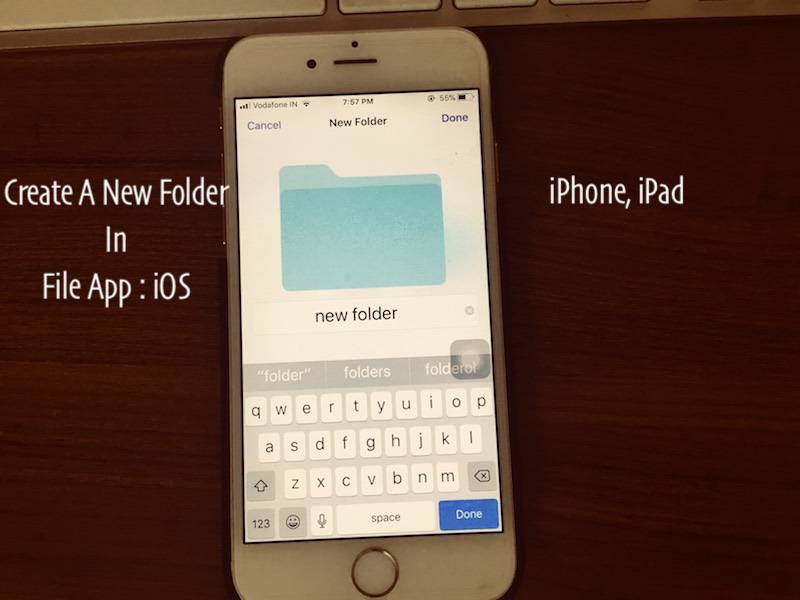Given the time and usage, should the user consider enabling any specific features to conserve battery? If so, which ones? At 7:57 PM with the battery at 56%, enabling battery-saving features could be wise to ensure the device lasts for the remainder of the evening. The user might consider enabling Low Power Mode, which reduces background activity like mail fetch, background app refresh, and automatic downloads. Additionally, reducing screen brightness, turning off unnecessary notifications, and limiting the use of location services and Bluetooth are practical steps to elongate battery life. These measures help make sure the device remains functional until it can be properly charged. Could enabling these features interfere with their current task of organizing files in any way? Enabling Low Power Mode and other battery-saving features is unlikely to significantly interfere with the task of organizing files. While some background functionalities might be limited, the core functionality of the File app should remain unaffected. The user can still create, move, and manage their files effectively. The slight inconvenience, if any, would be minimal compared to the benefit of extending the device's battery life, ensuring it remains operational for extended use. 